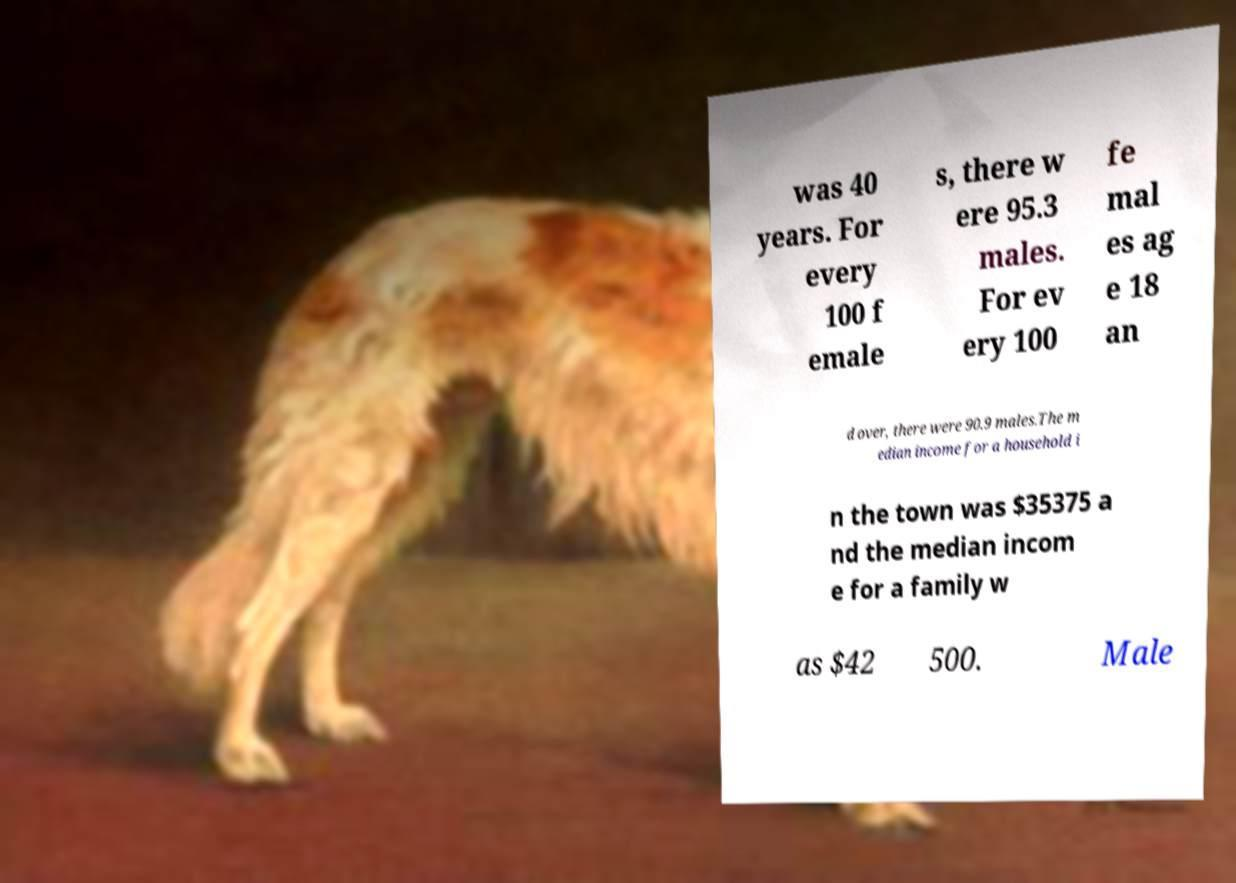For documentation purposes, I need the text within this image transcribed. Could you provide that? was 40 years. For every 100 f emale s, there w ere 95.3 males. For ev ery 100 fe mal es ag e 18 an d over, there were 90.9 males.The m edian income for a household i n the town was $35375 a nd the median incom e for a family w as $42 500. Male 